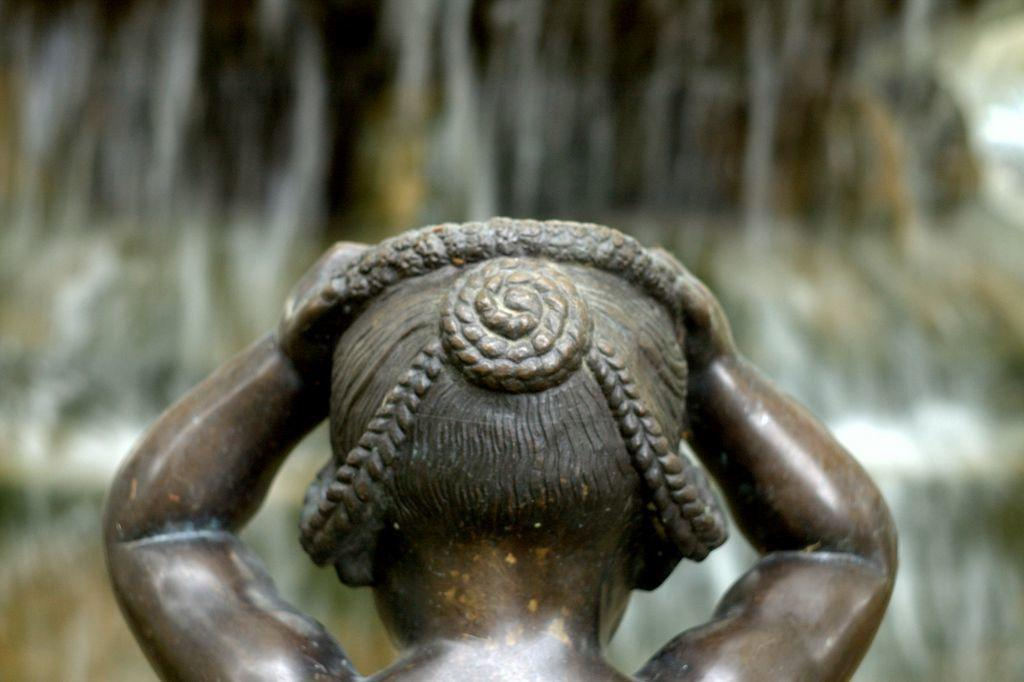What is the main subject of the image? There is a sculpture in the image. What color is the sculpture? The sculpture is brown in color. Can you describe the background of the image? The background of the image is blurred. What type of mist can be seen surrounding the sculpture in the image? There is no mist present in the image; the background is simply blurred. 